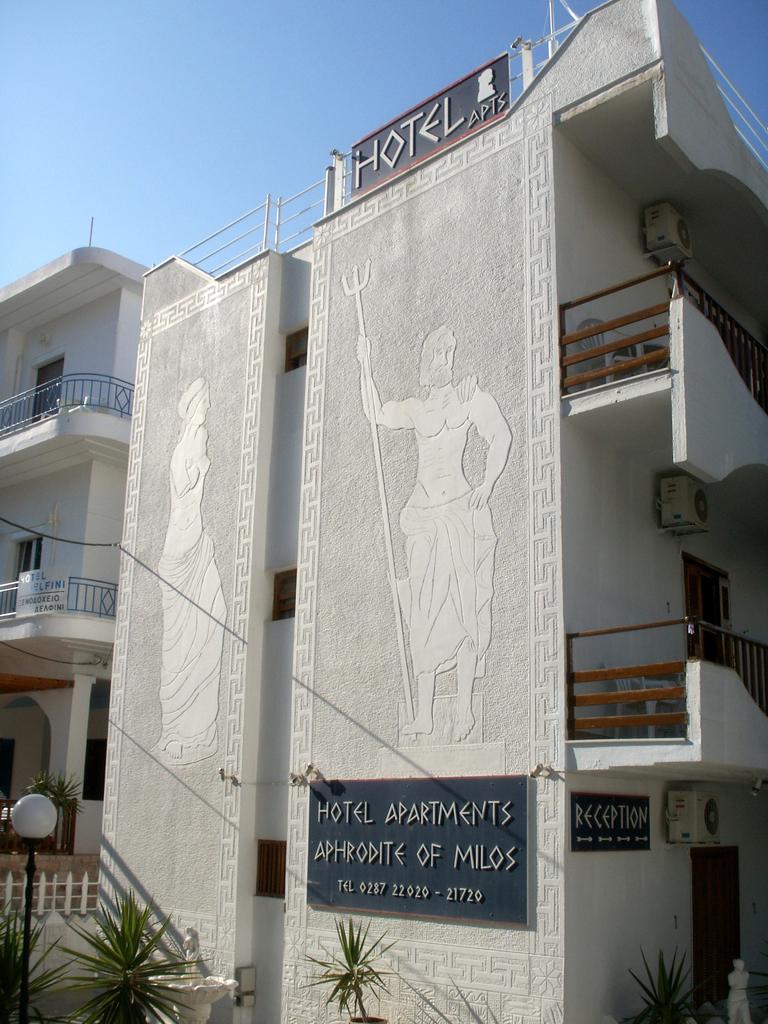Describe this image in one or two sentences. On the left side, there are plants near a pole which is having a light. On the right side, there is another pot plant near a white color statue and white wall of a building. Which is having glass windows, two paintings on the walls, hoardings and other objects. In the background, there is another building which is having glass windows and there is blue sky. 